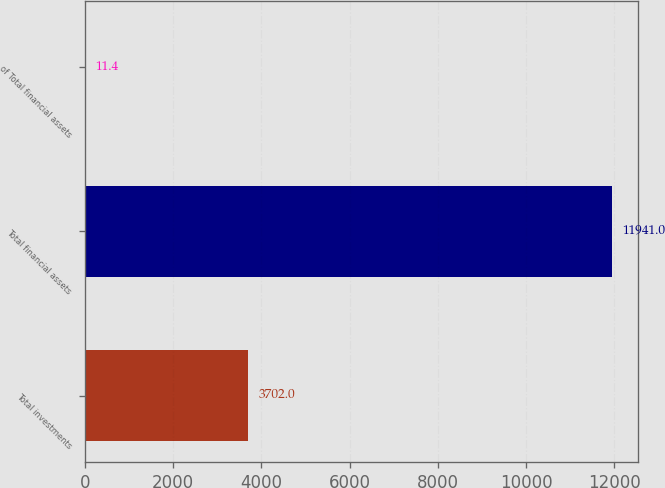Convert chart. <chart><loc_0><loc_0><loc_500><loc_500><bar_chart><fcel>Total investments<fcel>Total financial assets<fcel>of Total financial assets<nl><fcel>3702<fcel>11941<fcel>11.4<nl></chart> 